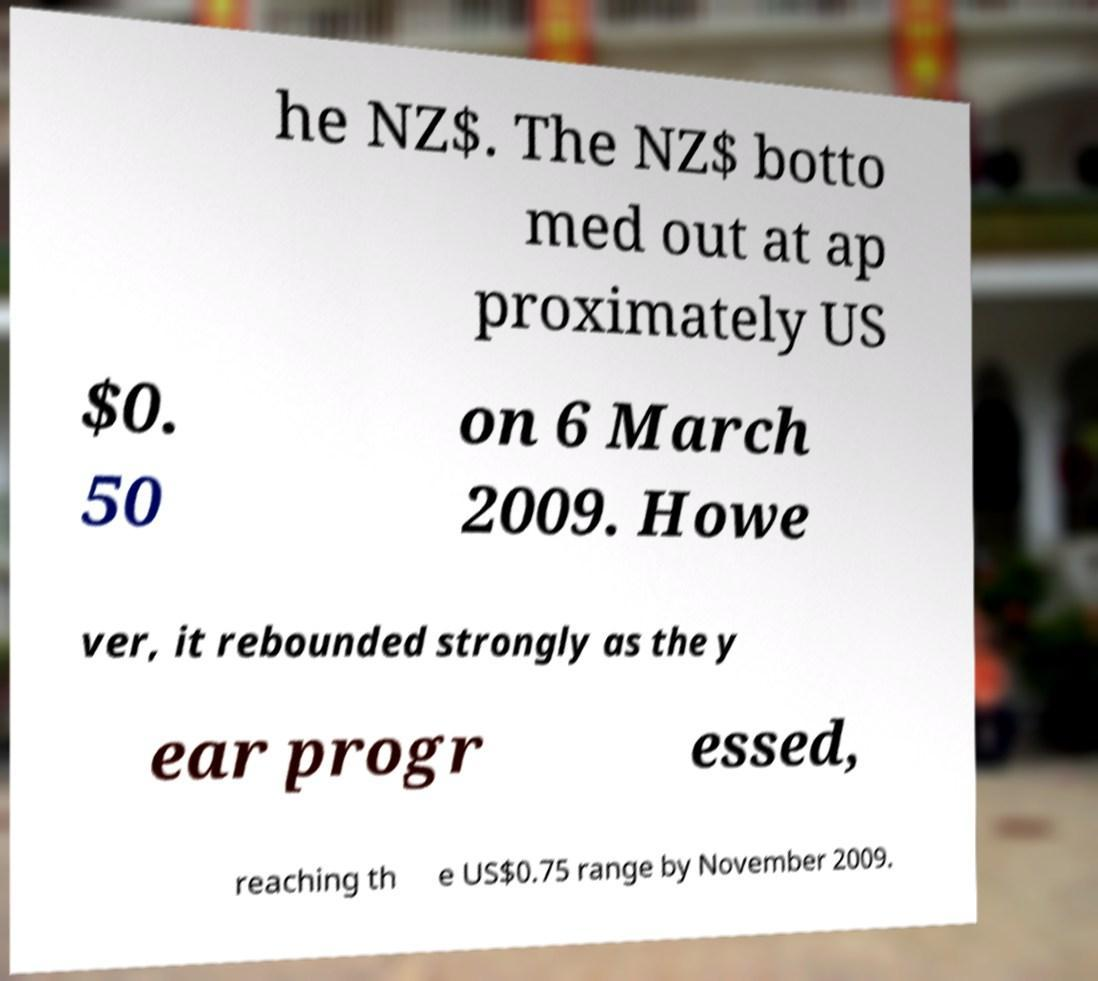I need the written content from this picture converted into text. Can you do that? he NZ$. The NZ$ botto med out at ap proximately US $0. 50 on 6 March 2009. Howe ver, it rebounded strongly as the y ear progr essed, reaching th e US$0.75 range by November 2009. 